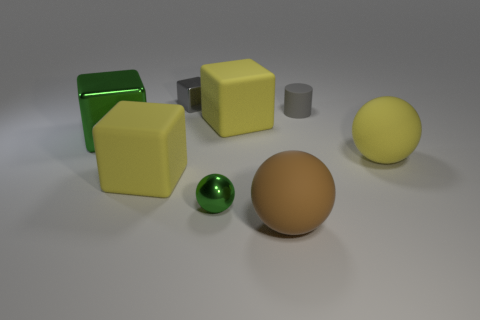Can you describe the various objects and their colors visible in this image? Certainly! The image displays a variety of geometric shapes. There is a large green cube with a reflective surface, two yellow cubes—one clearly bigger than the other—a small gray cylinder, and two spheres, one green and one orange, both with a matte finish. The objects are arranged on a neutral background, which helps to highlight their colors and shapes. 